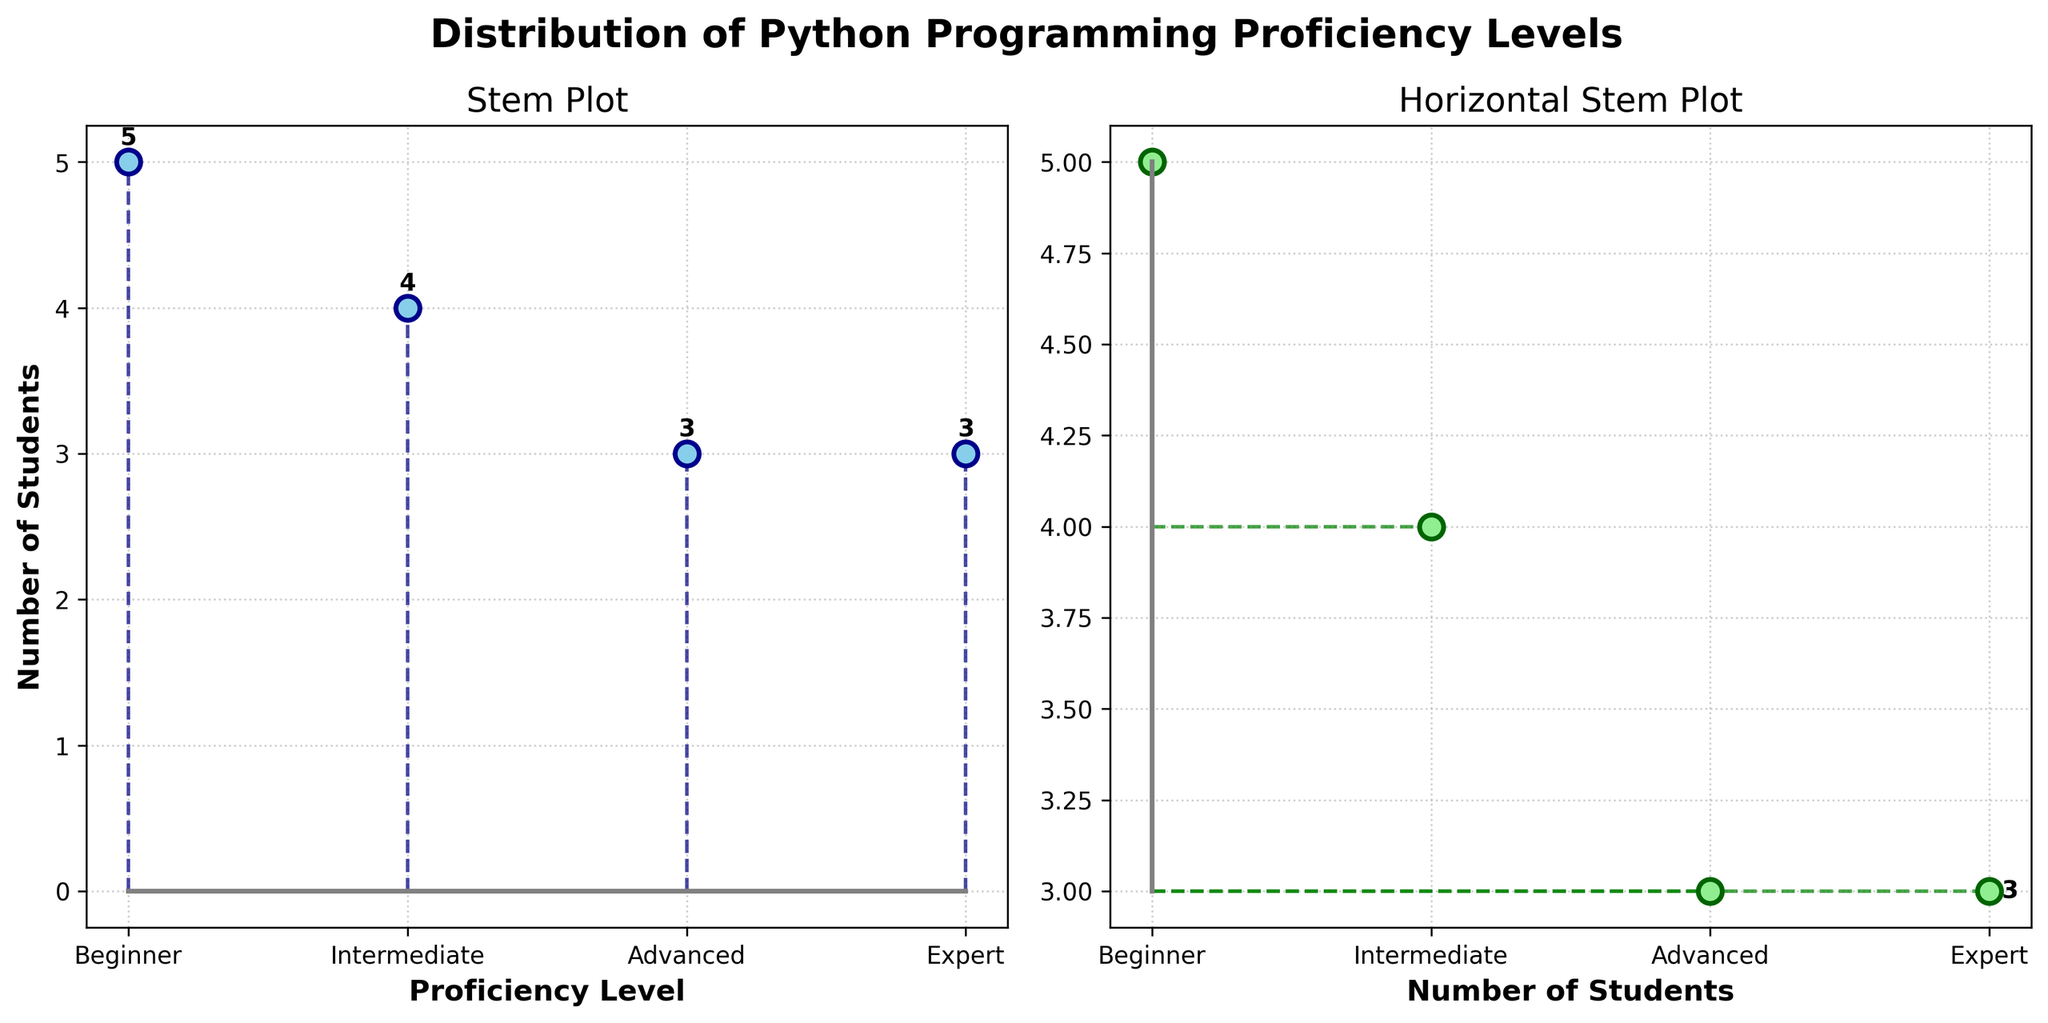What is the title of the figure? The title of the figure is written at the top of the plot. It reads "Distribution of Python Programming Proficiency Levels".
Answer: Distribution of Python Programming Proficiency Levels How many students fall into the 'Beginner' category in the right subplot? The right subplot is a horizontal stem plot. Look at the 'Beginner' label and find the annotated number next to the stem. It shows '5' students in that category.
Answer: 5 Which proficiency level has the highest number of students? Refer to either subplot and identify the stem with the highest value. Both subplots show that the 'Beginner' level has the highest count with '5' students.
Answer: Beginner How many students fall into the 'Intermediate' and 'Advanced' categories combined? Count the students in the 'Intermediate' (4) and 'Advanced' (3) categories, then add them together: 4 + 3 = 7.
Answer: 7 What color are the markers in the horizontal stem plot? The markers for the horizontal stem plot are depicted in a light green color.
Answer: Light green How many proficiency levels have exactly 3 students? By examining the annotations, we see that 'Advanced' has 3 students. Only one proficiency level has exactly 3 students.
Answer: 1 Which proficiency level has the fewest number of students? Observe the stems with the minimum height on either subplot. The 'Advanced' level has 3 students, fewer than all other levels.
Answer: Advanced What is the total number of students depicted in both subplots? Sum up the counts of all categorized levels: 5 (Beginner) + 4 (Intermediate) + 3 (Advanced) + 3 (Expert) = 15.
Answer: 15 